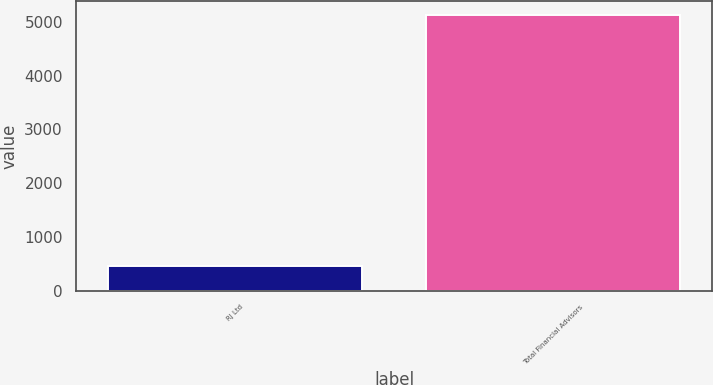Convert chart. <chart><loc_0><loc_0><loc_500><loc_500><bar_chart><fcel>RJ Ltd<fcel>Total Financial Advisors<nl><fcel>459<fcel>5127<nl></chart> 